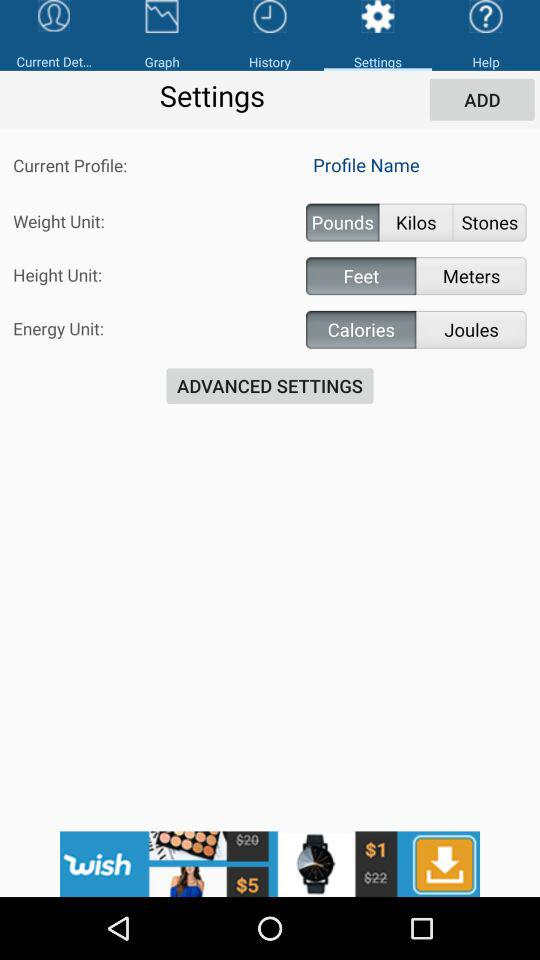What is the energy unit name? The energy unit names are calories and joules. 